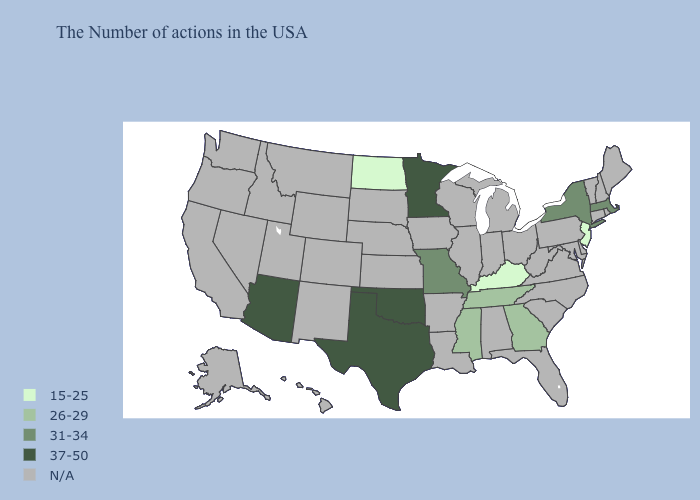What is the value of North Carolina?
Short answer required. N/A. What is the lowest value in states that border Nevada?
Concise answer only. 37-50. Which states hav the highest value in the South?
Keep it brief. Oklahoma, Texas. What is the value of Florida?
Write a very short answer. N/A. Does Kentucky have the lowest value in the South?
Concise answer only. Yes. What is the value of Montana?
Give a very brief answer. N/A. What is the lowest value in the USA?
Be succinct. 15-25. Among the states that border South Dakota , does North Dakota have the highest value?
Be succinct. No. Is the legend a continuous bar?
Answer briefly. No. Does Missouri have the highest value in the USA?
Answer briefly. No. Is the legend a continuous bar?
Concise answer only. No. Does Texas have the lowest value in the USA?
Answer briefly. No. What is the value of West Virginia?
Concise answer only. N/A. 